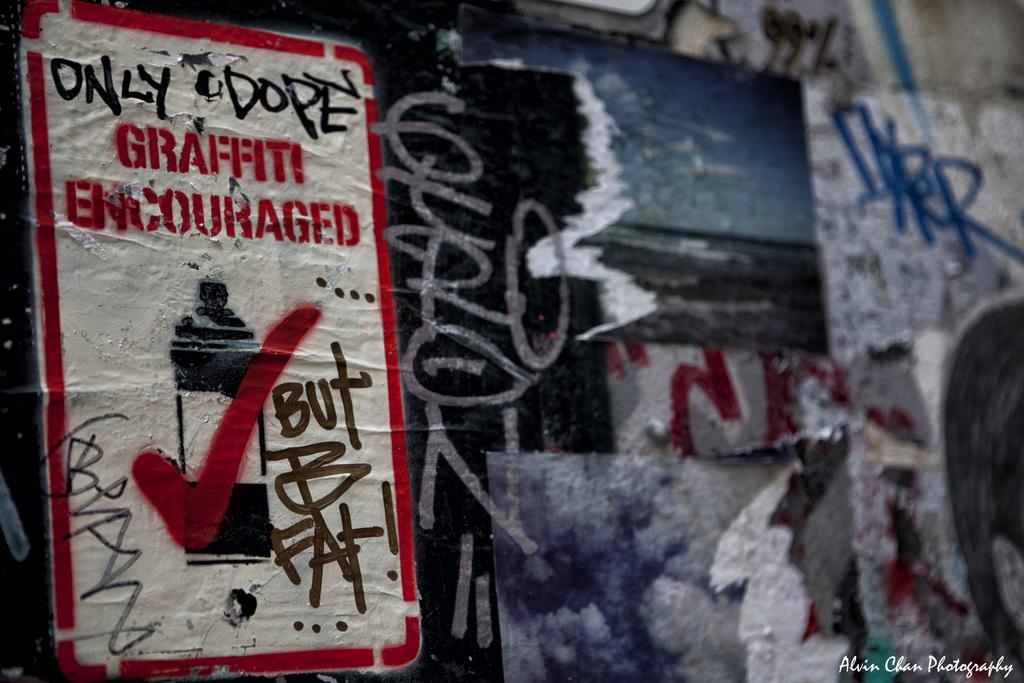What kind of graffiti do they encourage?
Your answer should be compact. Only dope. What does the sign say?
Your answer should be compact. Graffiti encouraged. 